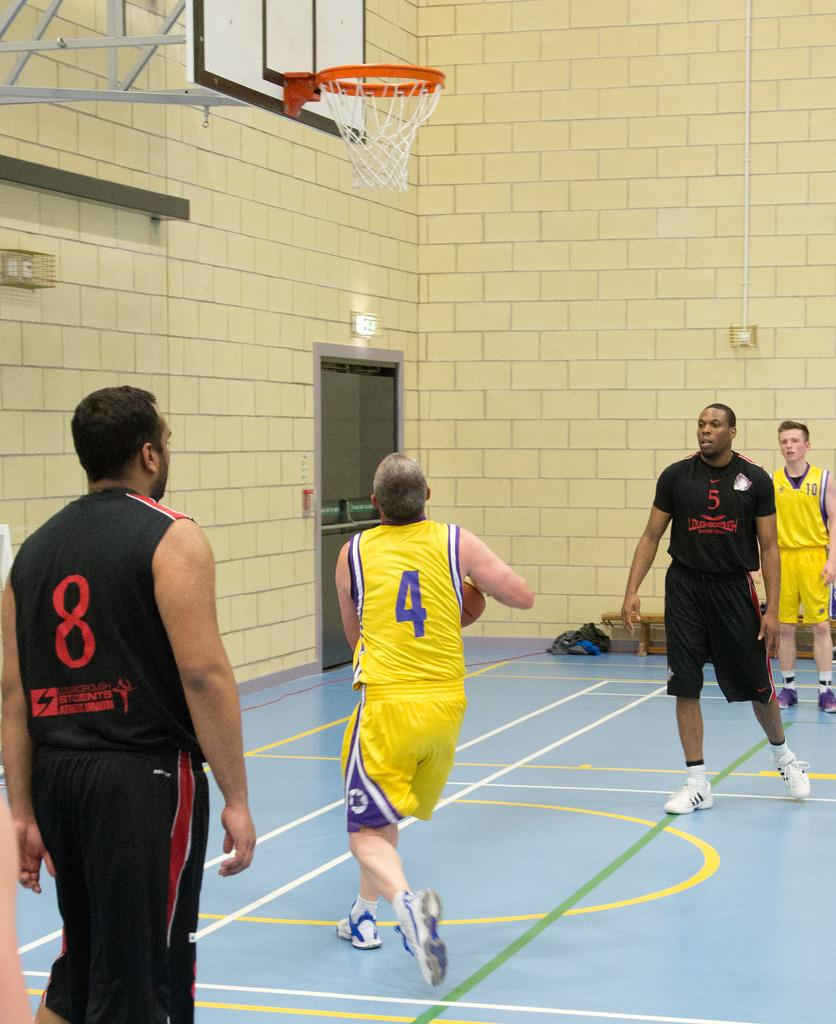<image>
Summarize the visual content of the image. Men playing basketball in black and yellow uniforms with 8 and 4 on their jerseys. 